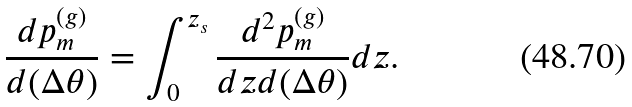<formula> <loc_0><loc_0><loc_500><loc_500>\frac { d p _ { m } ^ { ( g ) } } { d ( \Delta \theta ) } = \int _ { 0 } ^ { z _ { s } } \frac { d ^ { 2 } p _ { m } ^ { ( g ) } } { d z d ( \Delta \theta ) } d z .</formula> 